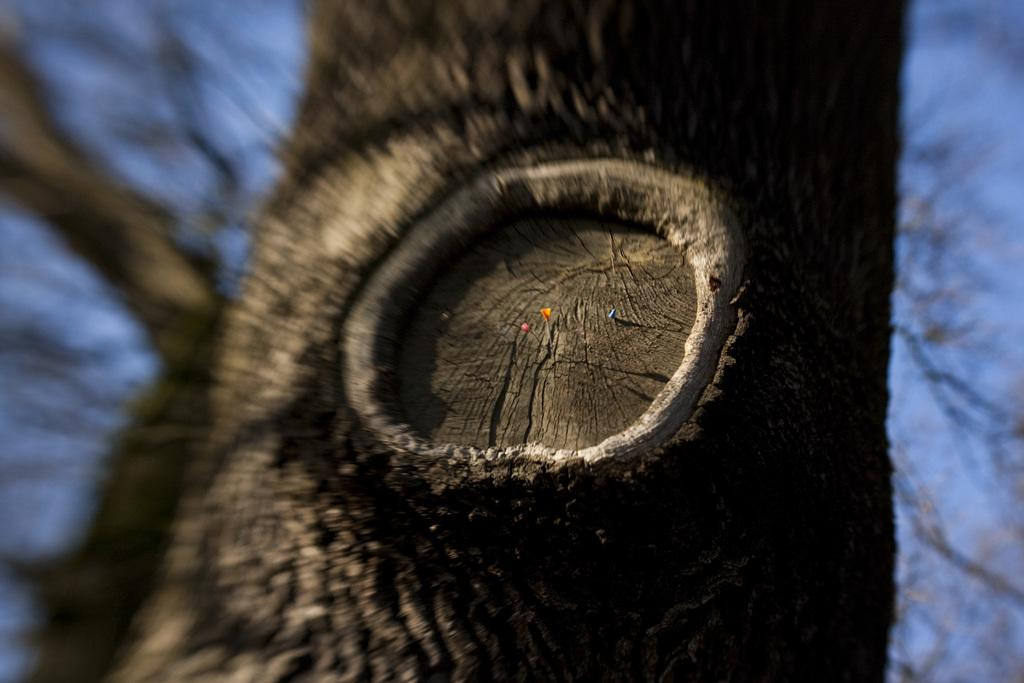What is the main subject of the image? The main subject of the image is a tree trunk. Can you describe the background of the image? The background of the image is blurry. What type of box is being used to capture the attention of the person in the image? There is no person or box present in the image; it only features a tree trunk and a blurry background. 